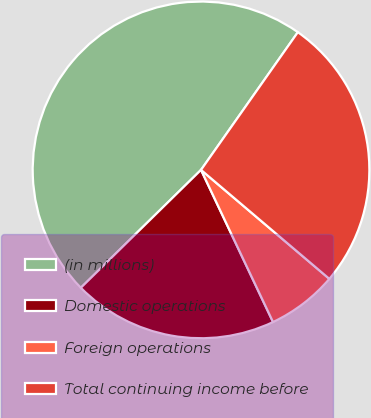Convert chart. <chart><loc_0><loc_0><loc_500><loc_500><pie_chart><fcel>(in millions)<fcel>Domestic operations<fcel>Foreign operations<fcel>Total continuing income before<nl><fcel>47.1%<fcel>19.69%<fcel>6.76%<fcel>26.45%<nl></chart> 